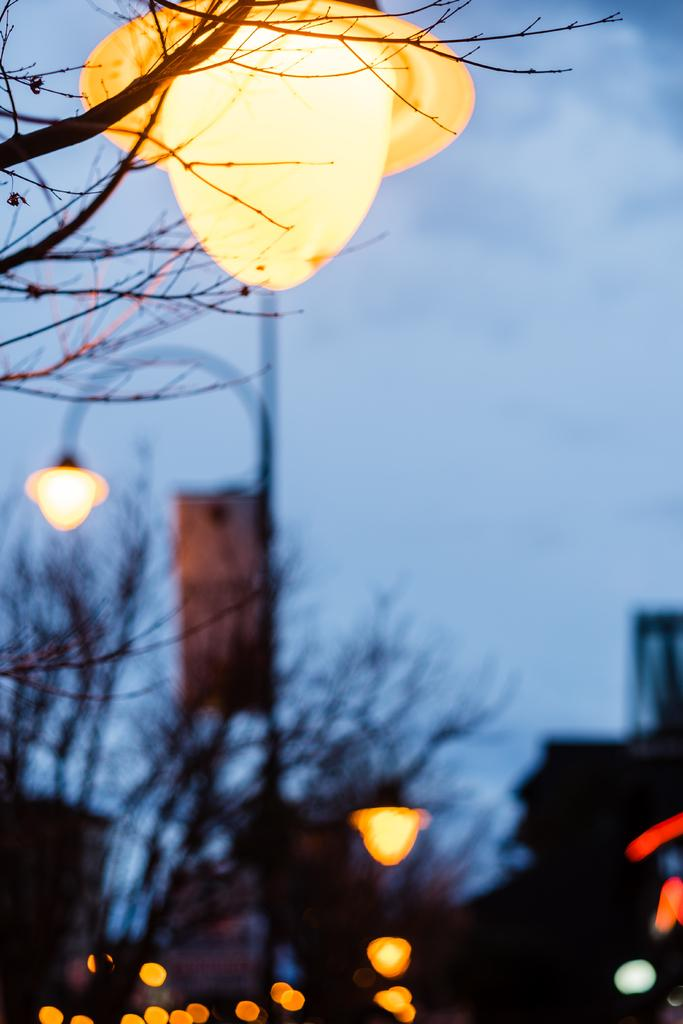What can be seen in the image that provides illumination? There are lights in the image. What type of natural elements are present in the image? There are trees in the image. What is visible in the background of the image? The sky is visible in the background of the image. What can be observed in the sky in the image? Clouds are present in the sky. What type of structure can be seen supporting the clouds in the image? There is no structure present in the image that supports the clouds; the clouds are simply floating in the sky. What type of cub is visible in the image? There is no cub present in the image. What type of seed can be seen growing on the trees in the image? There is no seed visible on the trees in the image; only the trees themselves are present. 